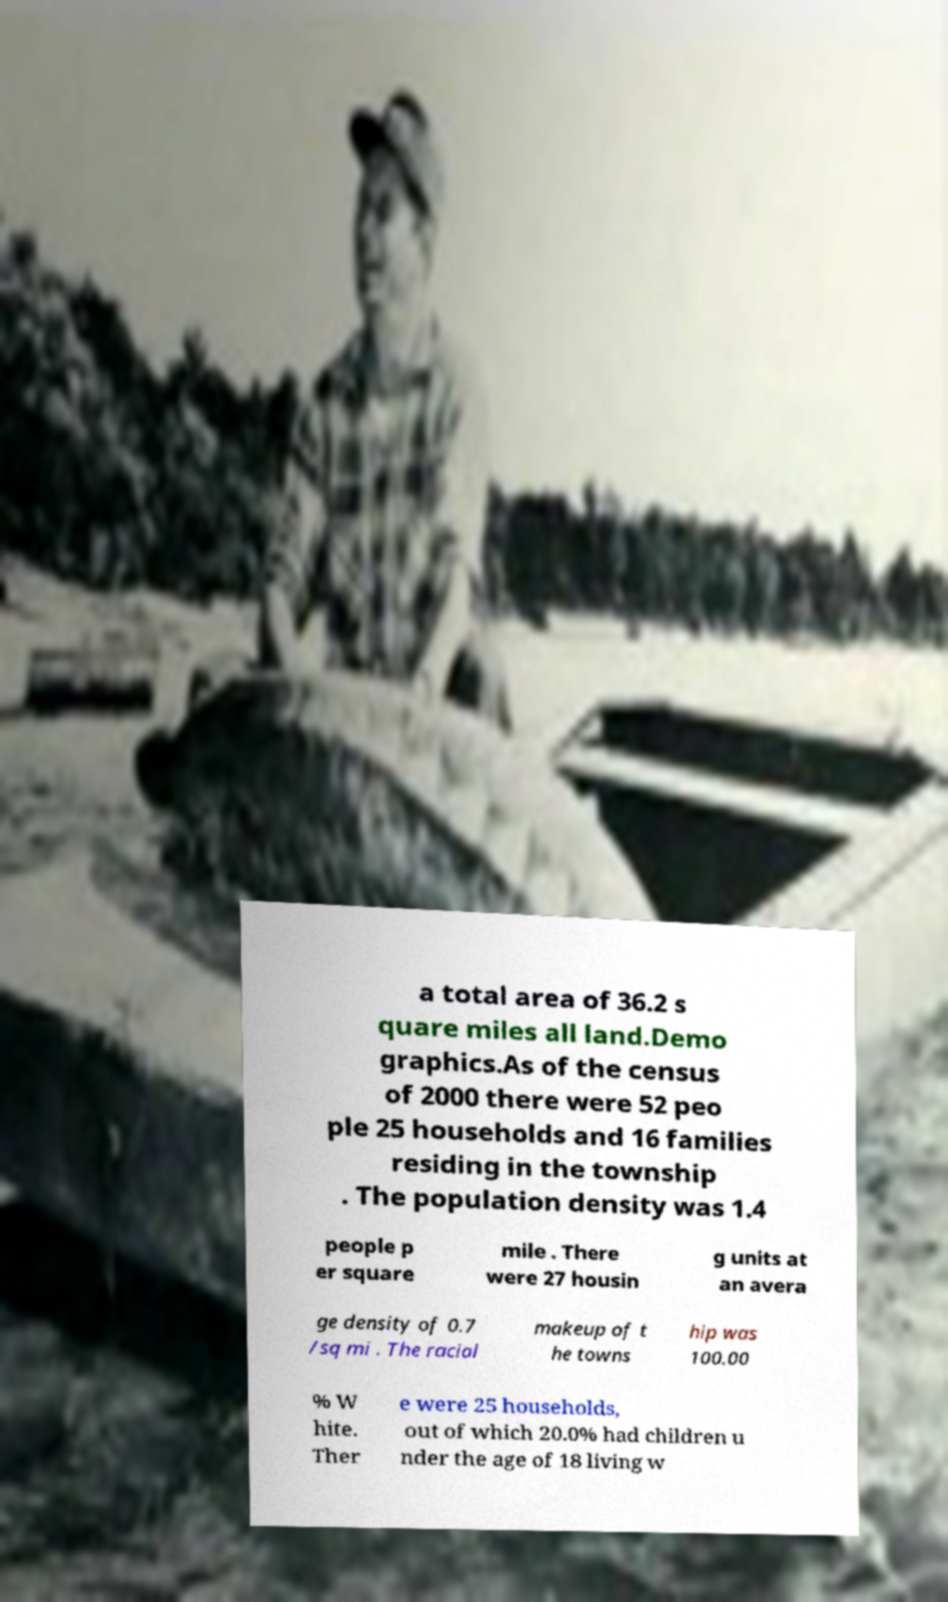Please identify and transcribe the text found in this image. a total area of 36.2 s quare miles all land.Demo graphics.As of the census of 2000 there were 52 peo ple 25 households and 16 families residing in the township . The population density was 1.4 people p er square mile . There were 27 housin g units at an avera ge density of 0.7 /sq mi . The racial makeup of t he towns hip was 100.00 % W hite. Ther e were 25 households, out of which 20.0% had children u nder the age of 18 living w 